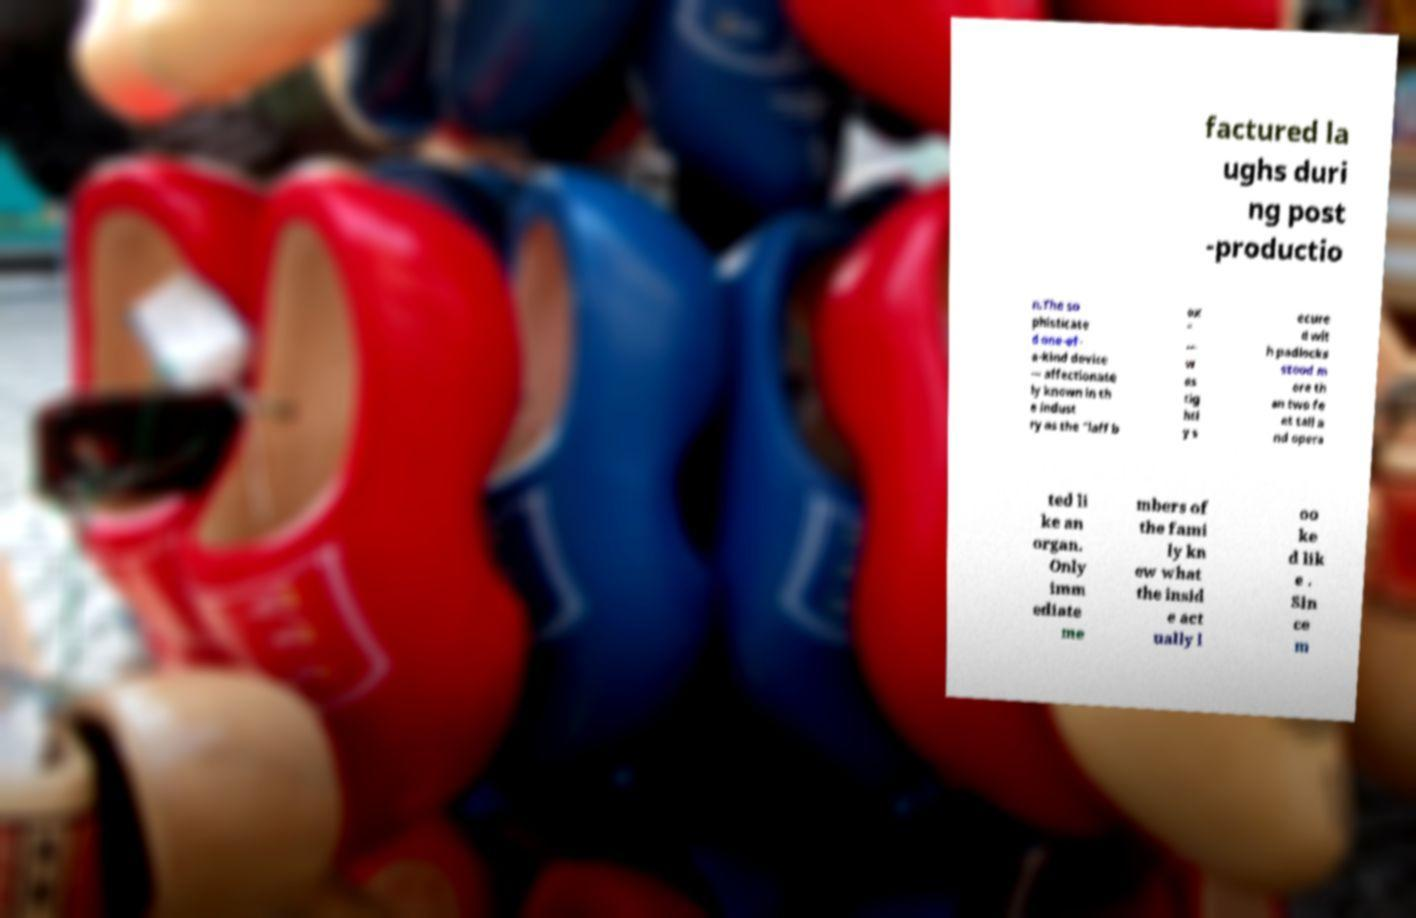Please identify and transcribe the text found in this image. factured la ughs duri ng post -productio n.The so phisticate d one-of- a-kind device — affectionate ly known in th e indust ry as the "laff b ox " — w as tig htl y s ecure d wit h padlocks stood m ore th an two fe et tall a nd opera ted li ke an organ. Only imm ediate me mbers of the fami ly kn ew what the insid e act ually l oo ke d lik e . Sin ce m 